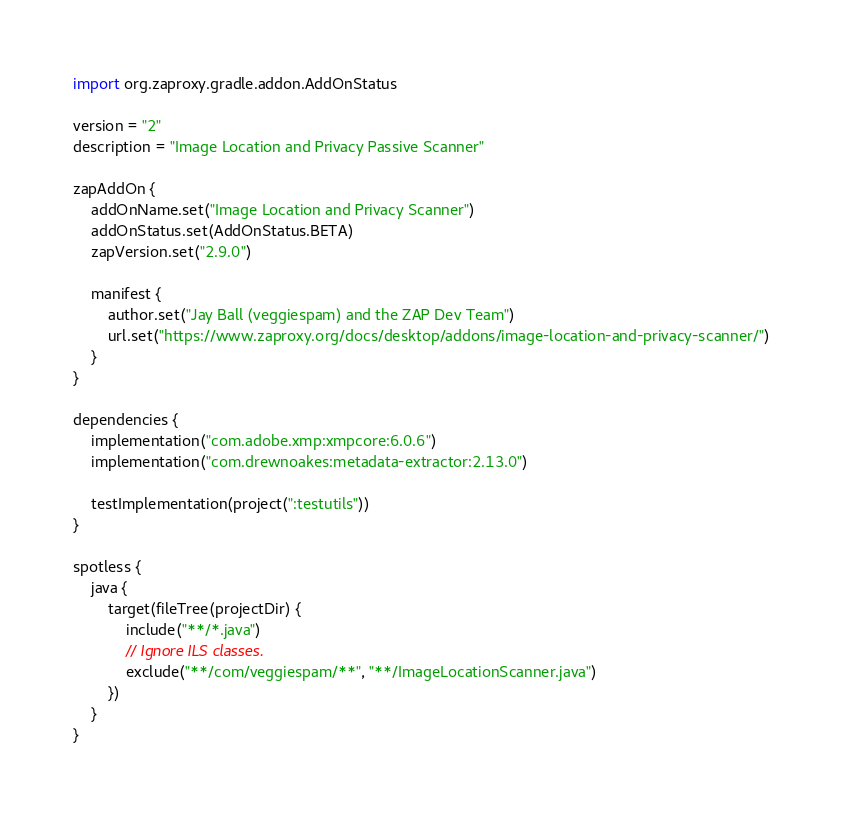Convert code to text. <code><loc_0><loc_0><loc_500><loc_500><_Kotlin_>import org.zaproxy.gradle.addon.AddOnStatus

version = "2"
description = "Image Location and Privacy Passive Scanner"

zapAddOn {
    addOnName.set("Image Location and Privacy Scanner")
    addOnStatus.set(AddOnStatus.BETA)
    zapVersion.set("2.9.0")

    manifest {
        author.set("Jay Ball (veggiespam) and the ZAP Dev Team")
        url.set("https://www.zaproxy.org/docs/desktop/addons/image-location-and-privacy-scanner/")
    }
}

dependencies {
    implementation("com.adobe.xmp:xmpcore:6.0.6")
    implementation("com.drewnoakes:metadata-extractor:2.13.0")

    testImplementation(project(":testutils"))
}

spotless {
    java {
        target(fileTree(projectDir) {
            include("**/*.java")
            // Ignore ILS classes.
            exclude("**/com/veggiespam/**", "**/ImageLocationScanner.java")
        })
    }
}
</code> 